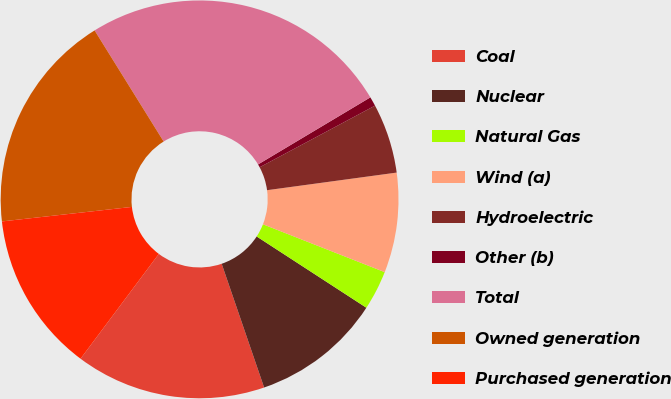<chart> <loc_0><loc_0><loc_500><loc_500><pie_chart><fcel>Coal<fcel>Nuclear<fcel>Natural Gas<fcel>Wind (a)<fcel>Hydroelectric<fcel>Other (b)<fcel>Total<fcel>Owned generation<fcel>Purchased generation<nl><fcel>15.47%<fcel>10.57%<fcel>3.21%<fcel>8.11%<fcel>5.66%<fcel>0.76%<fcel>25.28%<fcel>17.92%<fcel>13.02%<nl></chart> 